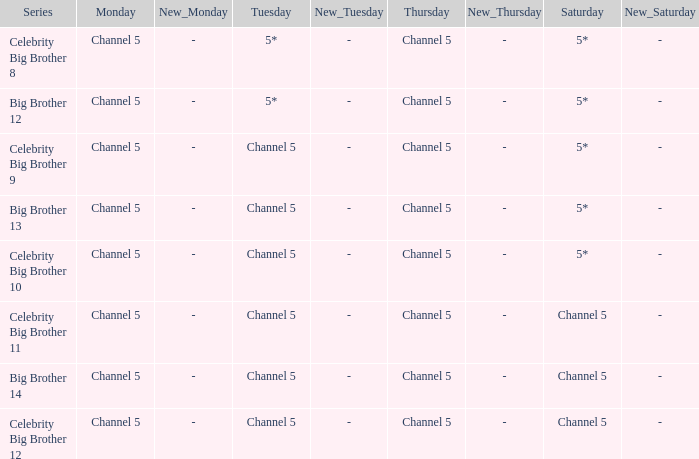Which Thursday does big brother 13 air? Channel 5. Parse the full table. {'header': ['Series', 'Monday', 'New_Monday', 'Tuesday', 'New_Tuesday', 'Thursday', 'New_Thursday', 'Saturday', 'New_Saturday'], 'rows': [['Celebrity Big Brother 8', 'Channel 5', '-', '5*', '-', 'Channel 5', '-', '5*', '-'], ['Big Brother 12', 'Channel 5', '-', '5*', '-', 'Channel 5', '-', '5*', '-'], ['Celebrity Big Brother 9', 'Channel 5', '-', 'Channel 5', '-', 'Channel 5', '-', '5*', '-'], ['Big Brother 13', 'Channel 5', '-', 'Channel 5', '-', 'Channel 5', '-', '5*', '-'], ['Celebrity Big Brother 10', 'Channel 5', '-', 'Channel 5', '-', 'Channel 5', '-', '5*', '-'], ['Celebrity Big Brother 11', 'Channel 5', '-', 'Channel 5', '-', 'Channel 5', '-', 'Channel 5', '-'], ['Big Brother 14', 'Channel 5', '-', 'Channel 5', '-', 'Channel 5', '-', 'Channel 5', '-'], ['Celebrity Big Brother 12', 'Channel 5', '-', 'Channel 5', '-', 'Channel 5', '-', 'Channel 5', '-']]} 